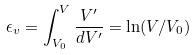Convert formula to latex. <formula><loc_0><loc_0><loc_500><loc_500>\epsilon _ { v } = \int _ { V _ { 0 } } ^ { V } \frac { V ^ { \prime } } { d V ^ { \prime } } = \ln ( V / V _ { 0 } )</formula> 